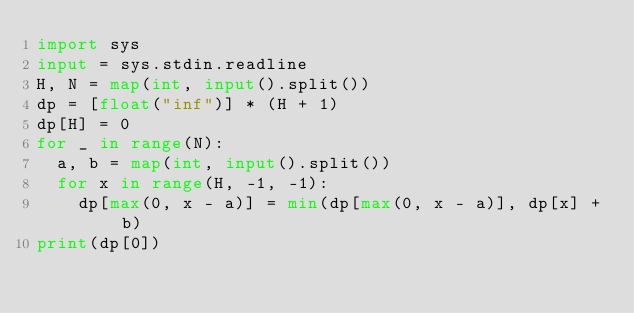<code> <loc_0><loc_0><loc_500><loc_500><_Python_>import sys
input = sys.stdin.readline
H, N = map(int, input().split())
dp = [float("inf")] * (H + 1)
dp[H] = 0
for _ in range(N):
  a, b = map(int, input().split())
  for x in range(H, -1, -1):
    dp[max(0, x - a)] = min(dp[max(0, x - a)], dp[x] + b)
print(dp[0])</code> 